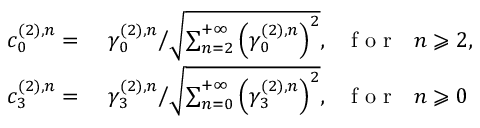<formula> <loc_0><loc_0><loc_500><loc_500>\begin{array} { r l } { c _ { 0 } ^ { ( 2 ) , n } = } & \ \gamma _ { 0 } ^ { ( 2 ) , n } \Big / \sqrt { \sum _ { n = 2 } ^ { + \infty } \left ( \gamma _ { 0 } ^ { ( 2 ) , n } \right ) ^ { 2 } } , f o r n \geqslant 2 , } \\ { c _ { 3 } ^ { ( 2 ) , n } = } & \ \gamma _ { 3 } ^ { ( 2 ) , n } \Big / \sqrt { \sum _ { n = 0 } ^ { + \infty } \left ( \gamma _ { 3 } ^ { ( 2 ) , n } \right ) ^ { 2 } } , f o r n \geqslant 0 } \end{array}</formula> 